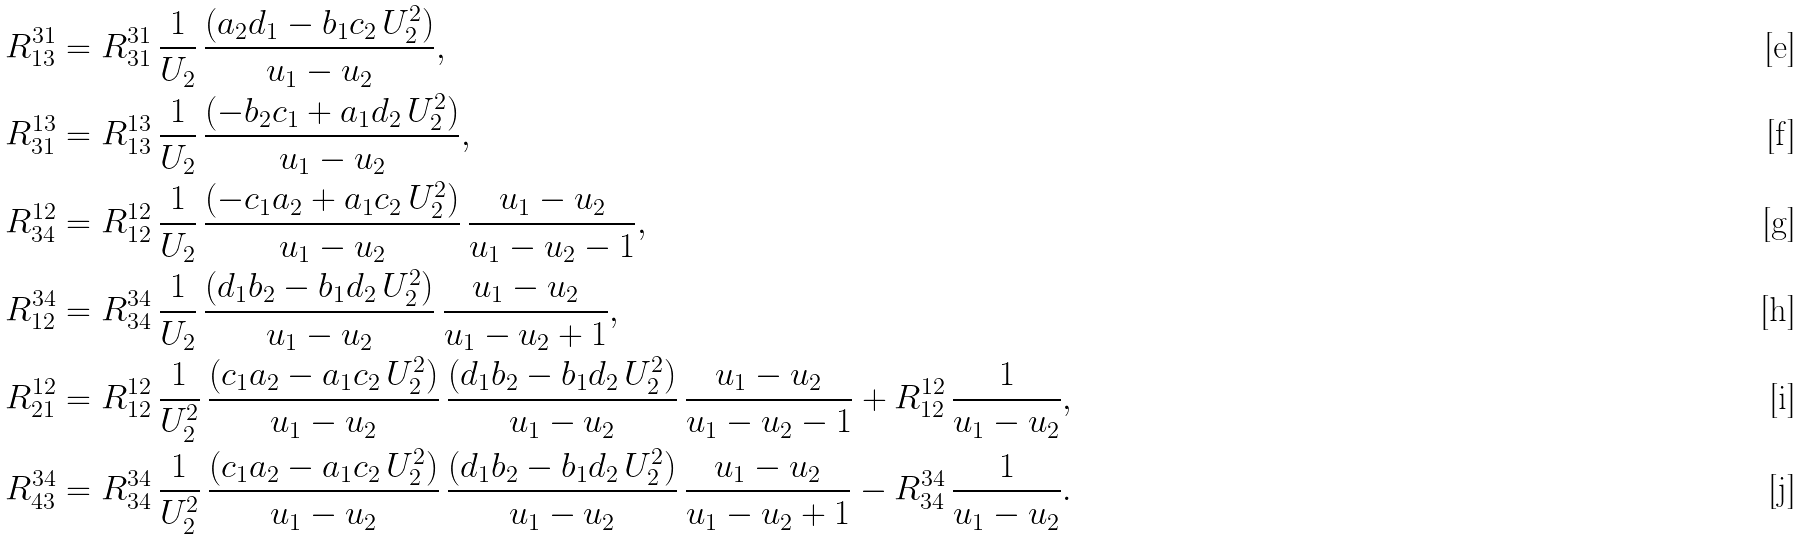Convert formula to latex. <formula><loc_0><loc_0><loc_500><loc_500>& R ^ { 3 1 } _ { 1 3 } = R ^ { 3 1 } _ { 3 1 } \, \frac { 1 } { U _ { 2 } } \, \frac { ( a _ { 2 } d _ { 1 } - b _ { 1 } c _ { 2 } \, U _ { 2 } ^ { 2 } ) } { u _ { 1 } - u _ { 2 } } , \\ & R ^ { 1 3 } _ { 3 1 } = R ^ { 1 3 } _ { 1 3 } \, \frac { 1 } { U _ { 2 } } \, \frac { ( - b _ { 2 } c _ { 1 } + a _ { 1 } d _ { 2 } \, U _ { 2 } ^ { 2 } ) } { u _ { 1 } - u _ { 2 } } , \\ & R ^ { 1 2 } _ { 3 4 } = R ^ { 1 2 } _ { 1 2 } \, \frac { 1 } { U _ { 2 } } \, \frac { ( - c _ { 1 } a _ { 2 } + a _ { 1 } c _ { 2 } \, U _ { 2 } ^ { 2 } ) } { u _ { 1 } - u _ { 2 } } \, \frac { u _ { 1 } - u _ { 2 } } { u _ { 1 } - u _ { 2 } - 1 } , \\ & R ^ { 3 4 } _ { 1 2 } = R ^ { 3 4 } _ { 3 4 } \, \frac { 1 } { U _ { 2 } } \, \frac { ( d _ { 1 } b _ { 2 } - b _ { 1 } d _ { 2 } \, U _ { 2 } ^ { 2 } ) } { u _ { 1 } - u _ { 2 } } \, \frac { u _ { 1 } - u _ { 2 } } { u _ { 1 } - u _ { 2 } + 1 } , \\ & R ^ { 1 2 } _ { 2 1 } = R ^ { 1 2 } _ { 1 2 } \, \frac { 1 } { U _ { 2 } ^ { 2 } } \, \frac { ( c _ { 1 } a _ { 2 } - a _ { 1 } c _ { 2 } \, U _ { 2 } ^ { 2 } ) } { u _ { 1 } - u _ { 2 } } \, \frac { ( d _ { 1 } b _ { 2 } - b _ { 1 } d _ { 2 } \, U _ { 2 } ^ { 2 } ) } { u _ { 1 } - u _ { 2 } } \, \frac { u _ { 1 } - u _ { 2 } } { u _ { 1 } - u _ { 2 } - 1 } + R ^ { 1 2 } _ { 1 2 } \, \frac { 1 } { u _ { 1 } - u _ { 2 } } , \\ & R ^ { 3 4 } _ { 4 3 } = R ^ { 3 4 } _ { 3 4 } \, \frac { 1 } { U _ { 2 } ^ { 2 } } \, \frac { ( c _ { 1 } a _ { 2 } - a _ { 1 } c _ { 2 } \, U _ { 2 } ^ { 2 } ) } { u _ { 1 } - u _ { 2 } } \, \frac { ( d _ { 1 } b _ { 2 } - b _ { 1 } d _ { 2 } \, U _ { 2 } ^ { 2 } ) } { u _ { 1 } - u _ { 2 } } \, \frac { u _ { 1 } - u _ { 2 } } { u _ { 1 } - u _ { 2 } + 1 } - R ^ { 3 4 } _ { 3 4 } \, \frac { 1 } { u _ { 1 } - u _ { 2 } } .</formula> 